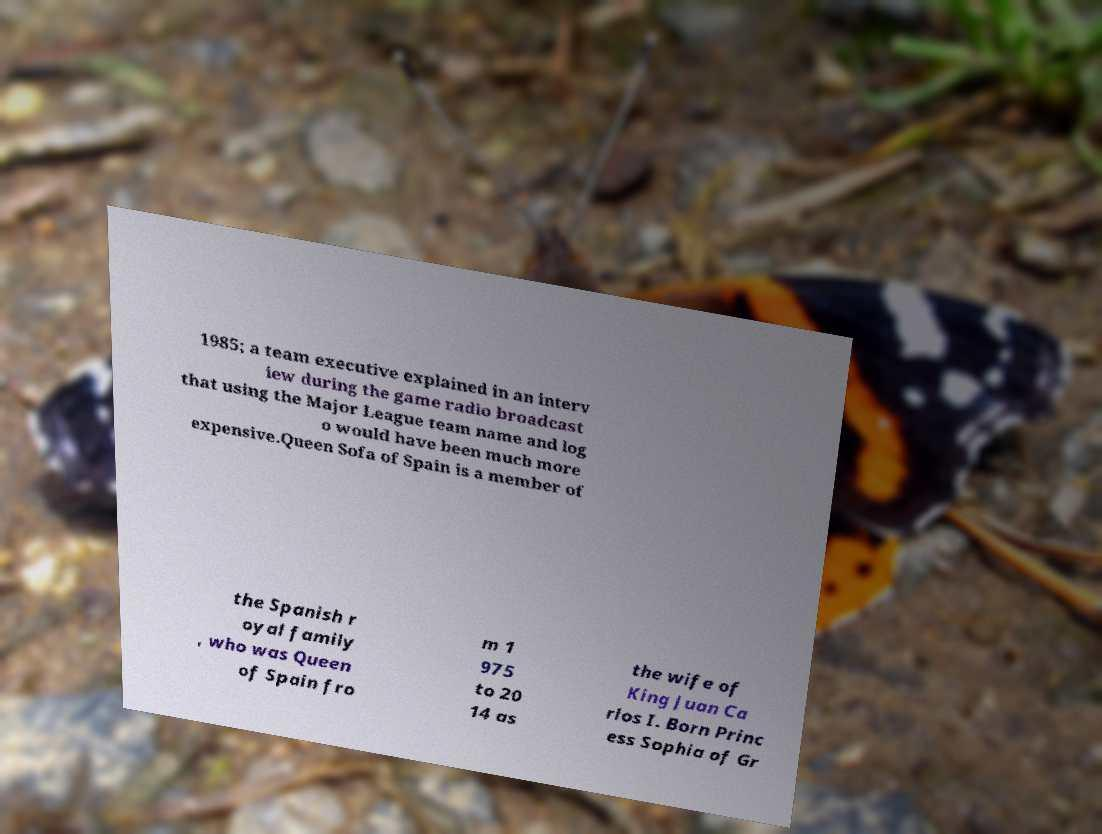What messages or text are displayed in this image? I need them in a readable, typed format. 1985; a team executive explained in an interv iew during the game radio broadcast that using the Major League team name and log o would have been much more expensive.Queen Sofa of Spain is a member of the Spanish r oyal family , who was Queen of Spain fro m 1 975 to 20 14 as the wife of King Juan Ca rlos I. Born Princ ess Sophia of Gr 